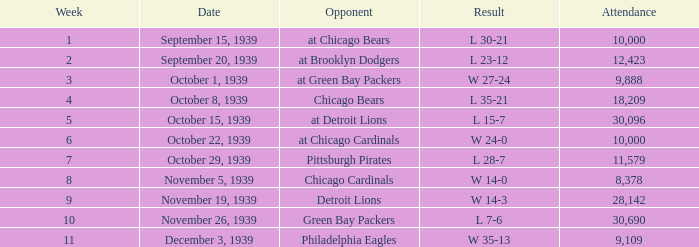Which attendance involves a green bay packers' rival and a week more than 10? None. 